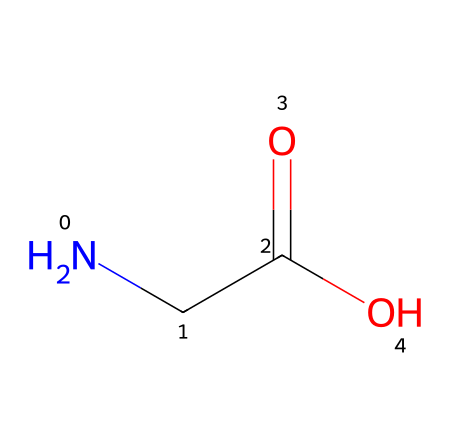What is the molecular formula of this structure? The SMILES representation indicates the presence of two nitrogen atoms, two carbon atoms, two oxygen atoms, and five hydrogen atoms. Counting these atoms gives the molecular formula as C2H5NO2.
Answer: C2H5NO2 How many carbon atoms are present in this amino acid? The SMILES shows "CC", which indicates there are two carbon atoms in the structure. Thus, the count of carbon atoms is two.
Answer: 2 What functional group is indicated in this structure? The presence of "C(=O)O" in the SMILES indicates a carboxylic acid functional group, characterized by the carbon double bonded to oxygen and also single bonded to a hydroxyl group.
Answer: carboxylic acid Which part of this chemical structure contributes to its basic nature? The presence of the nitrogen atom in the amine group (–NH2) connects to one of the carbon atoms, giving the structure its basic properties, as nitrogen can accept protons.
Answer: amine group How many total atoms are in this amino acid structure? By adding the total number of each type of atom: 2 carbon, 5 hydrogen, 1 nitrogen, and 2 oxygen, we get 10 total atoms.
Answer: 10 What type of monomer does this structure represent? This structure represents an amino acid, which is a type of monomer that combines to form proteins. The characteristics derived from the carboxylic acid and amine groups lead to its classification.
Answer: amino acid 